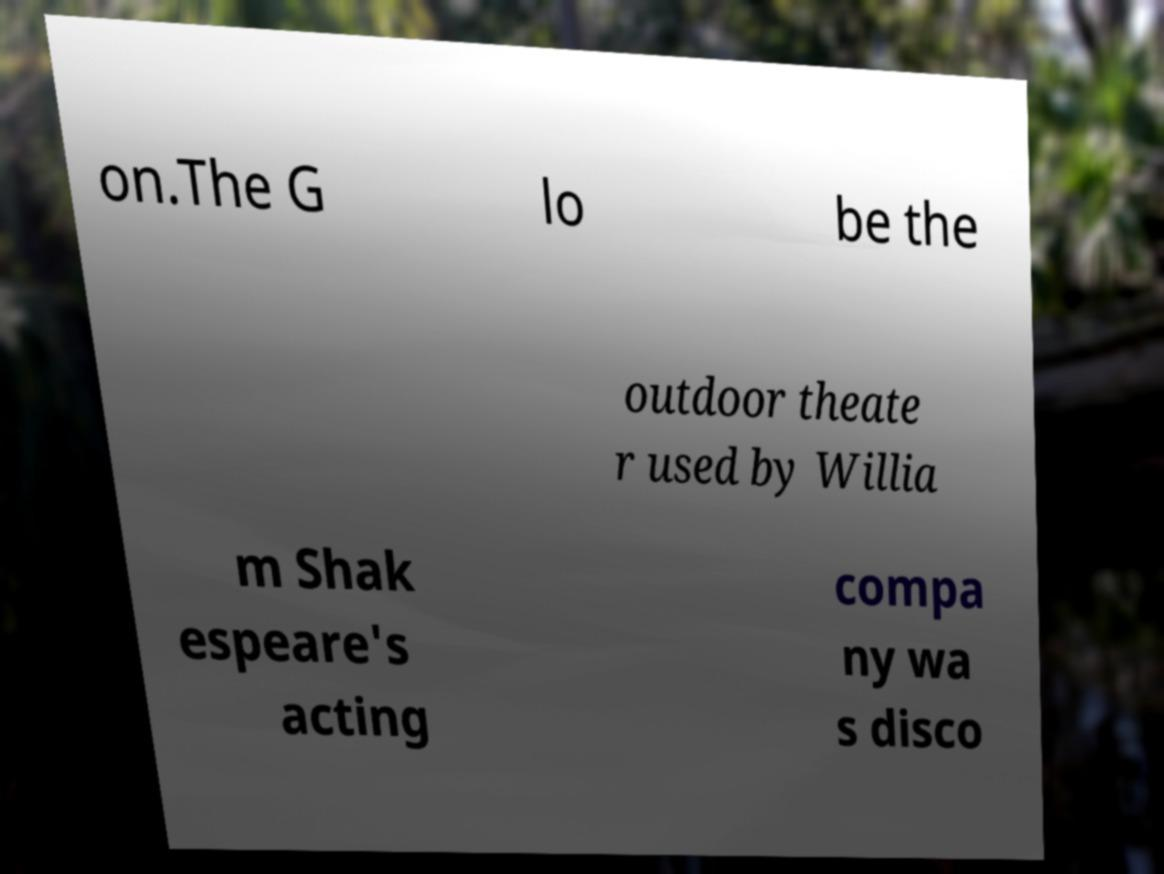Can you accurately transcribe the text from the provided image for me? on.The G lo be the outdoor theate r used by Willia m Shak espeare's acting compa ny wa s disco 